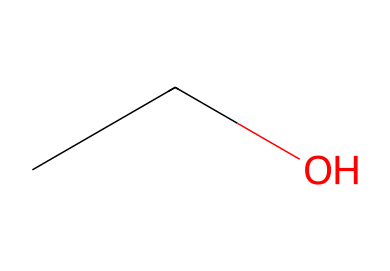What is the name of the compound represented by the SMILES notation CCO? The SMILES notation CCO corresponds to ethanol, which is a two-carbon aliphatic alcohol.
Answer: ethanol How many carbon (C) atoms are present in this structure? The structure represented by CCO contains two carbon atoms since there are two "C" letters in the notation.
Answer: 2 What type of functional group is present in ethanol? The presence of the -OH group in CCO indicates that ethanol contains a hydroxyl functional group, which is characteristic of alcohols.
Answer: hydroxyl How many hydrogen (H) atoms are in this compound? The SMILES CCO also shows that there are six hydrogen atoms in ethanol, calculated as 2 from each carbon plus 2 from the hydroxyl group (totaling 6).
Answer: 6 What type of compound is ethanol classified as? Ethanol is classified as an aliphatic compound because it consists of carbon and hydrogen in a straight-chain without aromatic rings.
Answer: aliphatic Why is ethanol effective as a sanitizing agent? Ethanol’s effectiveness as a sanitizer is attributed to its ability to disrupt microbial membranes, attributed to its hydroxyl functional group combined with its aliphatic structure.
Answer: disrupt microbial membranes 